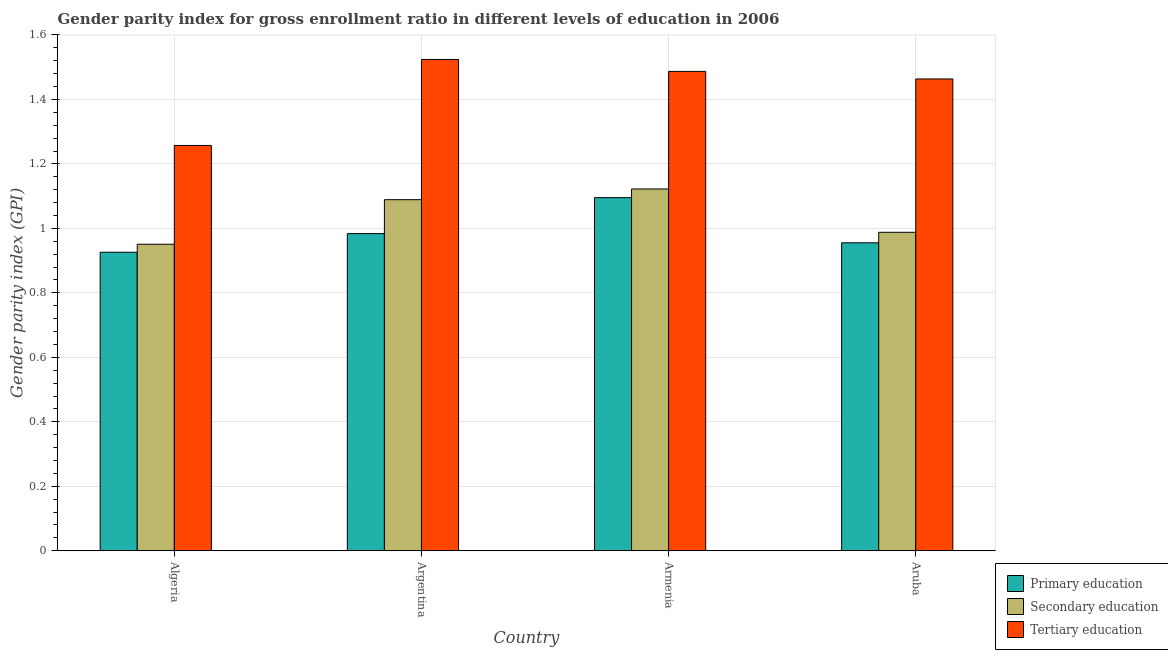How many different coloured bars are there?
Keep it short and to the point. 3. How many groups of bars are there?
Provide a short and direct response. 4. How many bars are there on the 1st tick from the left?
Offer a very short reply. 3. What is the label of the 4th group of bars from the left?
Ensure brevity in your answer.  Aruba. In how many cases, is the number of bars for a given country not equal to the number of legend labels?
Give a very brief answer. 0. What is the gender parity index in primary education in Algeria?
Provide a succinct answer. 0.93. Across all countries, what is the maximum gender parity index in tertiary education?
Your answer should be compact. 1.52. Across all countries, what is the minimum gender parity index in secondary education?
Offer a terse response. 0.95. In which country was the gender parity index in primary education maximum?
Provide a succinct answer. Armenia. In which country was the gender parity index in primary education minimum?
Offer a very short reply. Algeria. What is the total gender parity index in primary education in the graph?
Your answer should be very brief. 3.96. What is the difference between the gender parity index in primary education in Algeria and that in Argentina?
Offer a terse response. -0.06. What is the difference between the gender parity index in secondary education in Aruba and the gender parity index in primary education in Armenia?
Make the answer very short. -0.11. What is the average gender parity index in secondary education per country?
Your response must be concise. 1.04. What is the difference between the gender parity index in secondary education and gender parity index in tertiary education in Aruba?
Your answer should be very brief. -0.48. What is the ratio of the gender parity index in secondary education in Armenia to that in Aruba?
Offer a terse response. 1.14. What is the difference between the highest and the second highest gender parity index in secondary education?
Offer a very short reply. 0.03. What is the difference between the highest and the lowest gender parity index in tertiary education?
Ensure brevity in your answer.  0.27. In how many countries, is the gender parity index in tertiary education greater than the average gender parity index in tertiary education taken over all countries?
Your answer should be compact. 3. Is the sum of the gender parity index in primary education in Argentina and Aruba greater than the maximum gender parity index in secondary education across all countries?
Offer a very short reply. Yes. What does the 2nd bar from the right in Algeria represents?
Offer a very short reply. Secondary education. How many bars are there?
Offer a terse response. 12. Are the values on the major ticks of Y-axis written in scientific E-notation?
Provide a short and direct response. No. Where does the legend appear in the graph?
Keep it short and to the point. Bottom right. What is the title of the graph?
Provide a succinct answer. Gender parity index for gross enrollment ratio in different levels of education in 2006. What is the label or title of the Y-axis?
Give a very brief answer. Gender parity index (GPI). What is the Gender parity index (GPI) in Primary education in Algeria?
Make the answer very short. 0.93. What is the Gender parity index (GPI) in Secondary education in Algeria?
Your response must be concise. 0.95. What is the Gender parity index (GPI) of Tertiary education in Algeria?
Offer a very short reply. 1.26. What is the Gender parity index (GPI) of Primary education in Argentina?
Your response must be concise. 0.98. What is the Gender parity index (GPI) in Secondary education in Argentina?
Your answer should be very brief. 1.09. What is the Gender parity index (GPI) of Tertiary education in Argentina?
Keep it short and to the point. 1.52. What is the Gender parity index (GPI) in Primary education in Armenia?
Ensure brevity in your answer.  1.1. What is the Gender parity index (GPI) in Secondary education in Armenia?
Your answer should be compact. 1.12. What is the Gender parity index (GPI) of Tertiary education in Armenia?
Your answer should be very brief. 1.49. What is the Gender parity index (GPI) in Primary education in Aruba?
Provide a succinct answer. 0.96. What is the Gender parity index (GPI) of Secondary education in Aruba?
Ensure brevity in your answer.  0.99. What is the Gender parity index (GPI) in Tertiary education in Aruba?
Your response must be concise. 1.46. Across all countries, what is the maximum Gender parity index (GPI) of Primary education?
Make the answer very short. 1.1. Across all countries, what is the maximum Gender parity index (GPI) in Secondary education?
Give a very brief answer. 1.12. Across all countries, what is the maximum Gender parity index (GPI) in Tertiary education?
Your answer should be compact. 1.52. Across all countries, what is the minimum Gender parity index (GPI) of Primary education?
Make the answer very short. 0.93. Across all countries, what is the minimum Gender parity index (GPI) of Secondary education?
Your response must be concise. 0.95. Across all countries, what is the minimum Gender parity index (GPI) of Tertiary education?
Keep it short and to the point. 1.26. What is the total Gender parity index (GPI) in Primary education in the graph?
Give a very brief answer. 3.96. What is the total Gender parity index (GPI) in Secondary education in the graph?
Your answer should be very brief. 4.15. What is the total Gender parity index (GPI) of Tertiary education in the graph?
Make the answer very short. 5.73. What is the difference between the Gender parity index (GPI) in Primary education in Algeria and that in Argentina?
Your answer should be very brief. -0.06. What is the difference between the Gender parity index (GPI) in Secondary education in Algeria and that in Argentina?
Your answer should be compact. -0.14. What is the difference between the Gender parity index (GPI) in Tertiary education in Algeria and that in Argentina?
Ensure brevity in your answer.  -0.27. What is the difference between the Gender parity index (GPI) in Primary education in Algeria and that in Armenia?
Keep it short and to the point. -0.17. What is the difference between the Gender parity index (GPI) of Secondary education in Algeria and that in Armenia?
Provide a short and direct response. -0.17. What is the difference between the Gender parity index (GPI) of Tertiary education in Algeria and that in Armenia?
Your answer should be very brief. -0.23. What is the difference between the Gender parity index (GPI) in Primary education in Algeria and that in Aruba?
Ensure brevity in your answer.  -0.03. What is the difference between the Gender parity index (GPI) in Secondary education in Algeria and that in Aruba?
Give a very brief answer. -0.04. What is the difference between the Gender parity index (GPI) of Tertiary education in Algeria and that in Aruba?
Your answer should be compact. -0.21. What is the difference between the Gender parity index (GPI) of Primary education in Argentina and that in Armenia?
Offer a very short reply. -0.11. What is the difference between the Gender parity index (GPI) in Secondary education in Argentina and that in Armenia?
Ensure brevity in your answer.  -0.03. What is the difference between the Gender parity index (GPI) of Tertiary education in Argentina and that in Armenia?
Keep it short and to the point. 0.04. What is the difference between the Gender parity index (GPI) in Primary education in Argentina and that in Aruba?
Ensure brevity in your answer.  0.03. What is the difference between the Gender parity index (GPI) in Secondary education in Argentina and that in Aruba?
Your answer should be compact. 0.1. What is the difference between the Gender parity index (GPI) in Tertiary education in Argentina and that in Aruba?
Offer a very short reply. 0.06. What is the difference between the Gender parity index (GPI) of Primary education in Armenia and that in Aruba?
Make the answer very short. 0.14. What is the difference between the Gender parity index (GPI) in Secondary education in Armenia and that in Aruba?
Your answer should be very brief. 0.13. What is the difference between the Gender parity index (GPI) in Tertiary education in Armenia and that in Aruba?
Your answer should be very brief. 0.02. What is the difference between the Gender parity index (GPI) in Primary education in Algeria and the Gender parity index (GPI) in Secondary education in Argentina?
Your answer should be very brief. -0.16. What is the difference between the Gender parity index (GPI) of Primary education in Algeria and the Gender parity index (GPI) of Tertiary education in Argentina?
Give a very brief answer. -0.6. What is the difference between the Gender parity index (GPI) in Secondary education in Algeria and the Gender parity index (GPI) in Tertiary education in Argentina?
Provide a short and direct response. -0.57. What is the difference between the Gender parity index (GPI) in Primary education in Algeria and the Gender parity index (GPI) in Secondary education in Armenia?
Ensure brevity in your answer.  -0.2. What is the difference between the Gender parity index (GPI) of Primary education in Algeria and the Gender parity index (GPI) of Tertiary education in Armenia?
Provide a succinct answer. -0.56. What is the difference between the Gender parity index (GPI) of Secondary education in Algeria and the Gender parity index (GPI) of Tertiary education in Armenia?
Your answer should be very brief. -0.54. What is the difference between the Gender parity index (GPI) in Primary education in Algeria and the Gender parity index (GPI) in Secondary education in Aruba?
Ensure brevity in your answer.  -0.06. What is the difference between the Gender parity index (GPI) of Primary education in Algeria and the Gender parity index (GPI) of Tertiary education in Aruba?
Make the answer very short. -0.54. What is the difference between the Gender parity index (GPI) in Secondary education in Algeria and the Gender parity index (GPI) in Tertiary education in Aruba?
Your answer should be compact. -0.51. What is the difference between the Gender parity index (GPI) in Primary education in Argentina and the Gender parity index (GPI) in Secondary education in Armenia?
Give a very brief answer. -0.14. What is the difference between the Gender parity index (GPI) of Primary education in Argentina and the Gender parity index (GPI) of Tertiary education in Armenia?
Give a very brief answer. -0.5. What is the difference between the Gender parity index (GPI) in Secondary education in Argentina and the Gender parity index (GPI) in Tertiary education in Armenia?
Provide a short and direct response. -0.4. What is the difference between the Gender parity index (GPI) of Primary education in Argentina and the Gender parity index (GPI) of Secondary education in Aruba?
Your answer should be very brief. -0. What is the difference between the Gender parity index (GPI) in Primary education in Argentina and the Gender parity index (GPI) in Tertiary education in Aruba?
Ensure brevity in your answer.  -0.48. What is the difference between the Gender parity index (GPI) in Secondary education in Argentina and the Gender parity index (GPI) in Tertiary education in Aruba?
Your answer should be compact. -0.37. What is the difference between the Gender parity index (GPI) of Primary education in Armenia and the Gender parity index (GPI) of Secondary education in Aruba?
Provide a succinct answer. 0.11. What is the difference between the Gender parity index (GPI) in Primary education in Armenia and the Gender parity index (GPI) in Tertiary education in Aruba?
Offer a terse response. -0.37. What is the difference between the Gender parity index (GPI) of Secondary education in Armenia and the Gender parity index (GPI) of Tertiary education in Aruba?
Give a very brief answer. -0.34. What is the average Gender parity index (GPI) of Primary education per country?
Your answer should be compact. 0.99. What is the average Gender parity index (GPI) of Secondary education per country?
Offer a terse response. 1.04. What is the average Gender parity index (GPI) of Tertiary education per country?
Ensure brevity in your answer.  1.43. What is the difference between the Gender parity index (GPI) of Primary education and Gender parity index (GPI) of Secondary education in Algeria?
Offer a terse response. -0.02. What is the difference between the Gender parity index (GPI) of Primary education and Gender parity index (GPI) of Tertiary education in Algeria?
Provide a succinct answer. -0.33. What is the difference between the Gender parity index (GPI) of Secondary education and Gender parity index (GPI) of Tertiary education in Algeria?
Your response must be concise. -0.31. What is the difference between the Gender parity index (GPI) in Primary education and Gender parity index (GPI) in Secondary education in Argentina?
Provide a short and direct response. -0.11. What is the difference between the Gender parity index (GPI) of Primary education and Gender parity index (GPI) of Tertiary education in Argentina?
Offer a very short reply. -0.54. What is the difference between the Gender parity index (GPI) of Secondary education and Gender parity index (GPI) of Tertiary education in Argentina?
Your answer should be compact. -0.43. What is the difference between the Gender parity index (GPI) of Primary education and Gender parity index (GPI) of Secondary education in Armenia?
Offer a very short reply. -0.03. What is the difference between the Gender parity index (GPI) of Primary education and Gender parity index (GPI) of Tertiary education in Armenia?
Offer a very short reply. -0.39. What is the difference between the Gender parity index (GPI) of Secondary education and Gender parity index (GPI) of Tertiary education in Armenia?
Provide a short and direct response. -0.36. What is the difference between the Gender parity index (GPI) of Primary education and Gender parity index (GPI) of Secondary education in Aruba?
Your response must be concise. -0.03. What is the difference between the Gender parity index (GPI) in Primary education and Gender parity index (GPI) in Tertiary education in Aruba?
Offer a very short reply. -0.51. What is the difference between the Gender parity index (GPI) in Secondary education and Gender parity index (GPI) in Tertiary education in Aruba?
Keep it short and to the point. -0.48. What is the ratio of the Gender parity index (GPI) in Primary education in Algeria to that in Argentina?
Your answer should be compact. 0.94. What is the ratio of the Gender parity index (GPI) in Secondary education in Algeria to that in Argentina?
Ensure brevity in your answer.  0.87. What is the ratio of the Gender parity index (GPI) in Tertiary education in Algeria to that in Argentina?
Provide a short and direct response. 0.82. What is the ratio of the Gender parity index (GPI) of Primary education in Algeria to that in Armenia?
Give a very brief answer. 0.85. What is the ratio of the Gender parity index (GPI) of Secondary education in Algeria to that in Armenia?
Your answer should be very brief. 0.85. What is the ratio of the Gender parity index (GPI) in Tertiary education in Algeria to that in Armenia?
Provide a succinct answer. 0.85. What is the ratio of the Gender parity index (GPI) of Primary education in Algeria to that in Aruba?
Offer a very short reply. 0.97. What is the ratio of the Gender parity index (GPI) in Secondary education in Algeria to that in Aruba?
Provide a short and direct response. 0.96. What is the ratio of the Gender parity index (GPI) of Tertiary education in Algeria to that in Aruba?
Offer a very short reply. 0.86. What is the ratio of the Gender parity index (GPI) in Primary education in Argentina to that in Armenia?
Offer a terse response. 0.9. What is the ratio of the Gender parity index (GPI) in Secondary education in Argentina to that in Armenia?
Your answer should be compact. 0.97. What is the ratio of the Gender parity index (GPI) of Tertiary education in Argentina to that in Armenia?
Your answer should be very brief. 1.02. What is the ratio of the Gender parity index (GPI) in Primary education in Argentina to that in Aruba?
Offer a terse response. 1.03. What is the ratio of the Gender parity index (GPI) in Secondary education in Argentina to that in Aruba?
Your answer should be compact. 1.1. What is the ratio of the Gender parity index (GPI) of Tertiary education in Argentina to that in Aruba?
Give a very brief answer. 1.04. What is the ratio of the Gender parity index (GPI) in Primary education in Armenia to that in Aruba?
Your response must be concise. 1.15. What is the ratio of the Gender parity index (GPI) of Secondary education in Armenia to that in Aruba?
Your answer should be compact. 1.14. What is the ratio of the Gender parity index (GPI) in Tertiary education in Armenia to that in Aruba?
Give a very brief answer. 1.02. What is the difference between the highest and the second highest Gender parity index (GPI) in Primary education?
Offer a terse response. 0.11. What is the difference between the highest and the second highest Gender parity index (GPI) in Secondary education?
Make the answer very short. 0.03. What is the difference between the highest and the second highest Gender parity index (GPI) in Tertiary education?
Provide a succinct answer. 0.04. What is the difference between the highest and the lowest Gender parity index (GPI) of Primary education?
Give a very brief answer. 0.17. What is the difference between the highest and the lowest Gender parity index (GPI) of Secondary education?
Provide a succinct answer. 0.17. What is the difference between the highest and the lowest Gender parity index (GPI) in Tertiary education?
Your response must be concise. 0.27. 